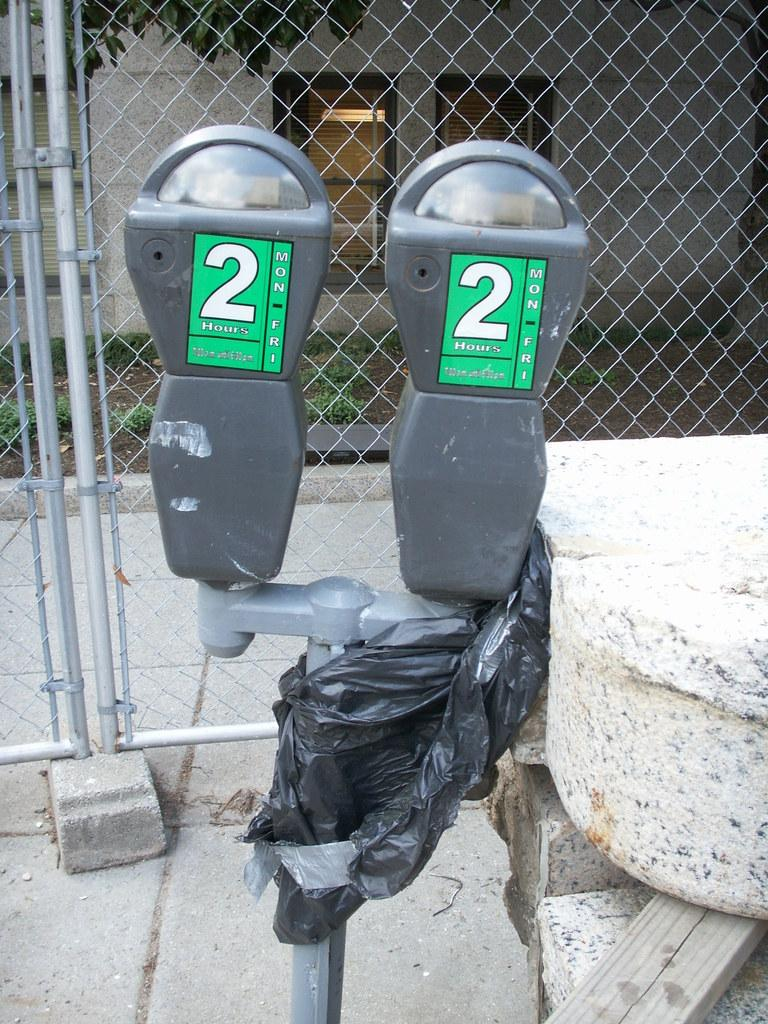<image>
Summarize the visual content of the image. Two parking meters with a black plastic bag tied on them that have the number 2 on them. 